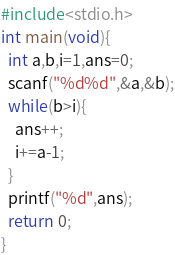Convert code to text. <code><loc_0><loc_0><loc_500><loc_500><_C_>#include<stdio.h>
int main(void){
  int a,b,i=1,ans=0;
  scanf("%d%d",&a,&b);
  while(b>i){
    ans++;
    i+=a-1;
  }
  printf("%d",ans);
  return 0;
}
</code> 